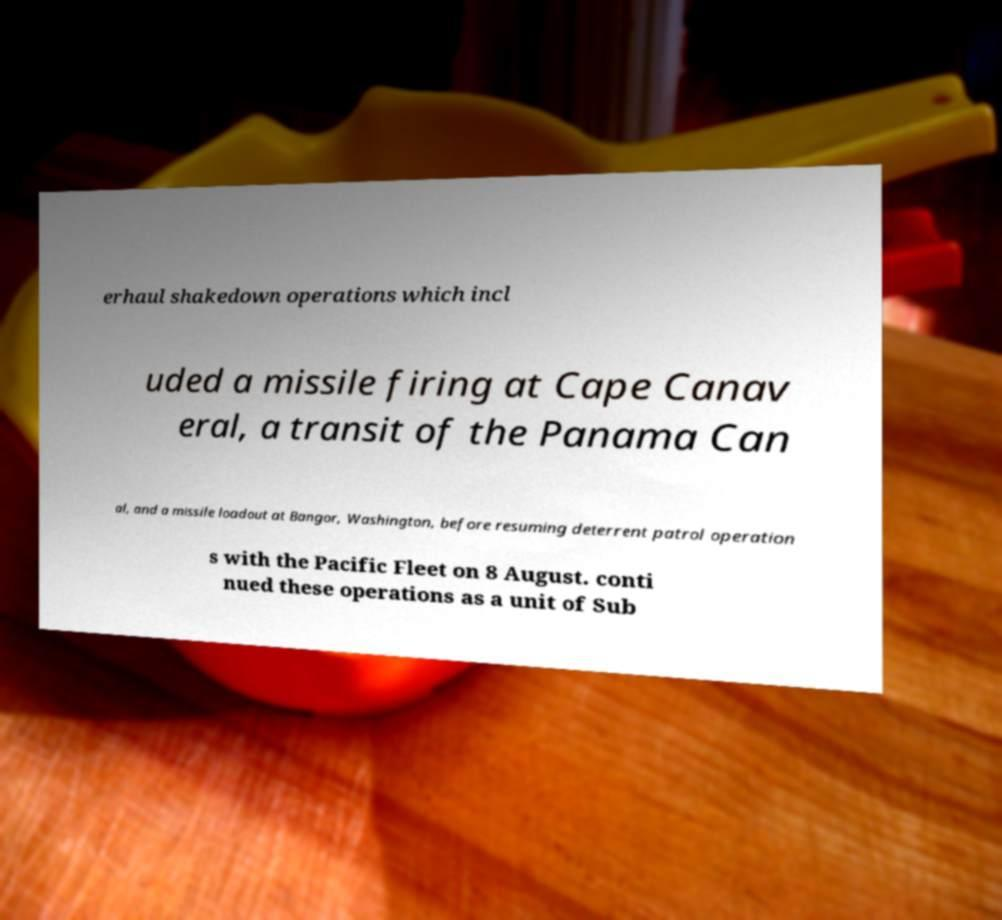Could you assist in decoding the text presented in this image and type it out clearly? erhaul shakedown operations which incl uded a missile firing at Cape Canav eral, a transit of the Panama Can al, and a missile loadout at Bangor, Washington, before resuming deterrent patrol operation s with the Pacific Fleet on 8 August. conti nued these operations as a unit of Sub 